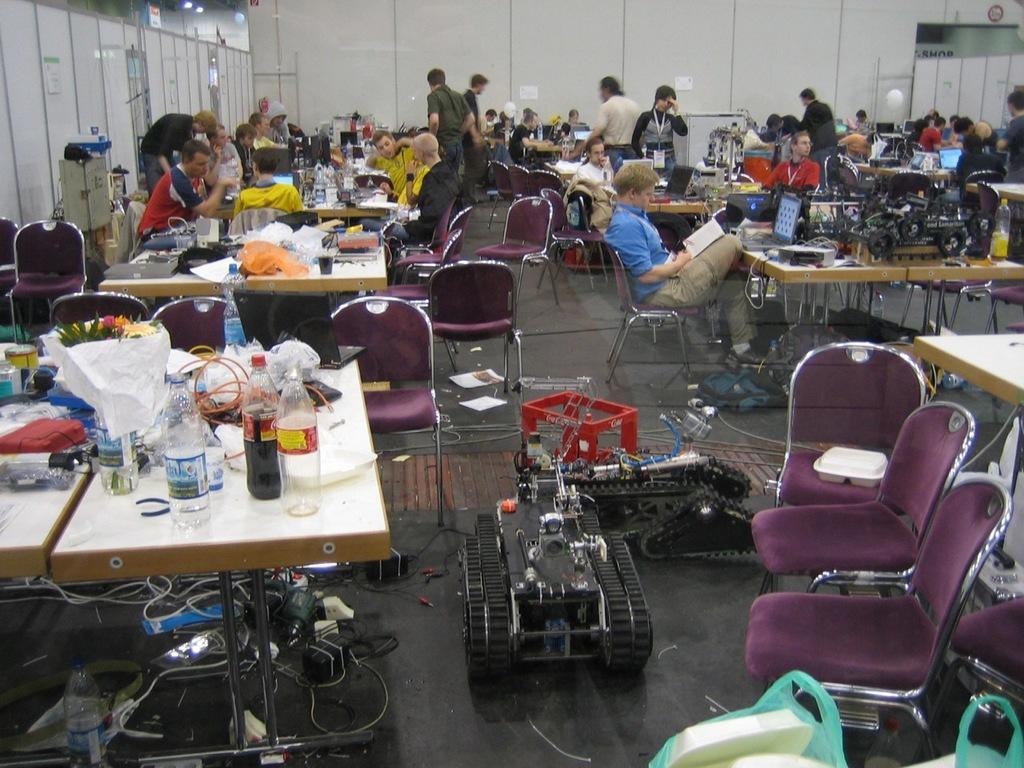Could you give a brief overview of what you see in this image? In this image there are a few people sitting on the chairs and few people are standing on the floor. In front of them there are tables. On top of it there are bottles, laptops and a few other objects. In front of the image there are chairs. There is a machine. At the bottom of the image there are wires. In the background of the image there is a wall. On the left side of the image there is some object. 